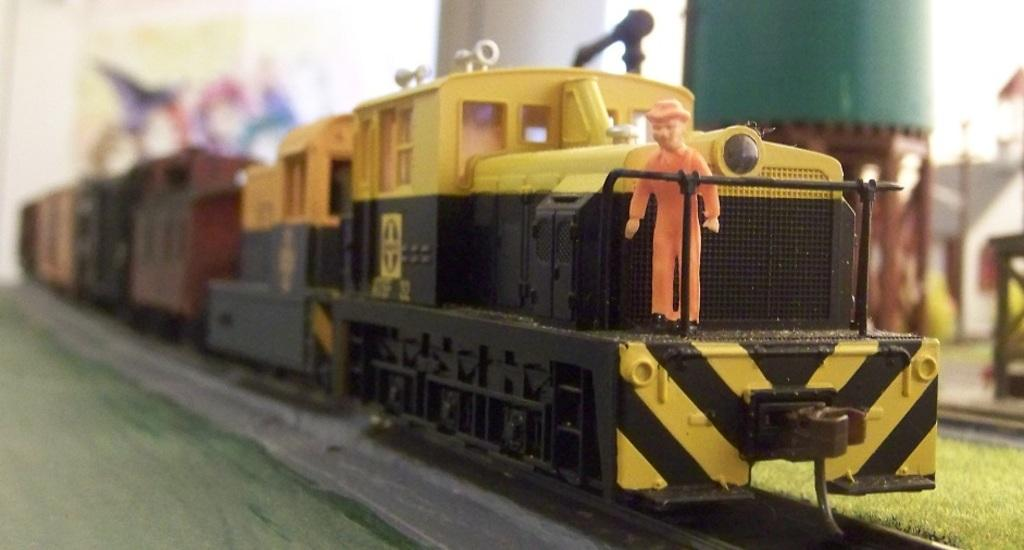What is the main subject of the image? The main subject of the image is a train. Can you describe the train's position in the image? The train is on a track in the image. What is the color of the train? The train is yellow in color. Is there anyone else present in the image besides the train? Yes, there is a man standing in the image. What can be seen in the background of the image? There is a pillar in the background of the image. How does the train contribute to the man's wealth in the image? The image does not provide any information about the man's wealth or how the train might be related to it. 